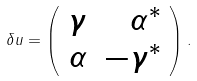Convert formula to latex. <formula><loc_0><loc_0><loc_500><loc_500>\delta u = \left ( \begin{array} { l r } \gamma & \alpha ^ { * } \\ \alpha & - \gamma ^ { * } \end{array} \right ) .</formula> 